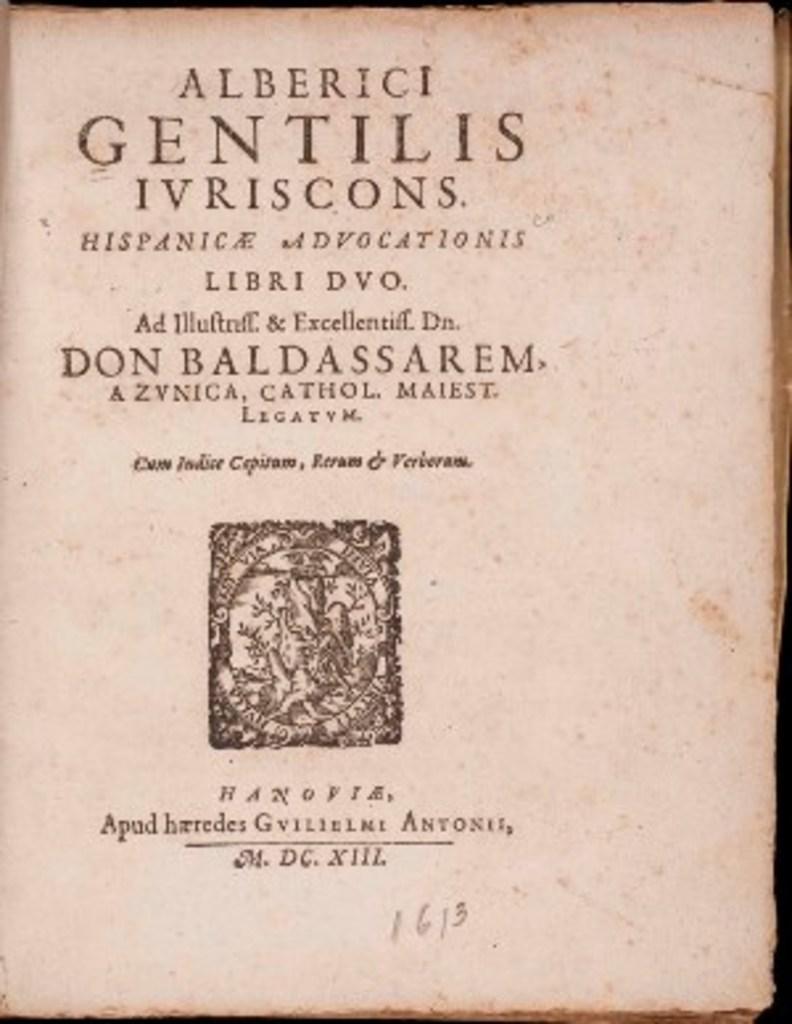Who wrote this book?
Provide a short and direct response. Don baldassarem. 